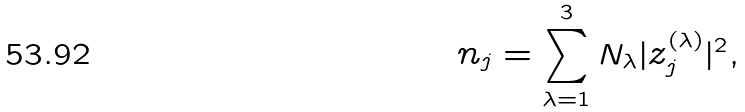<formula> <loc_0><loc_0><loc_500><loc_500>n _ { j } = \sum _ { \lambda = 1 } ^ { 3 } N _ { \lambda } | z ^ { ( \lambda ) } _ { j } | ^ { 2 } ,</formula> 